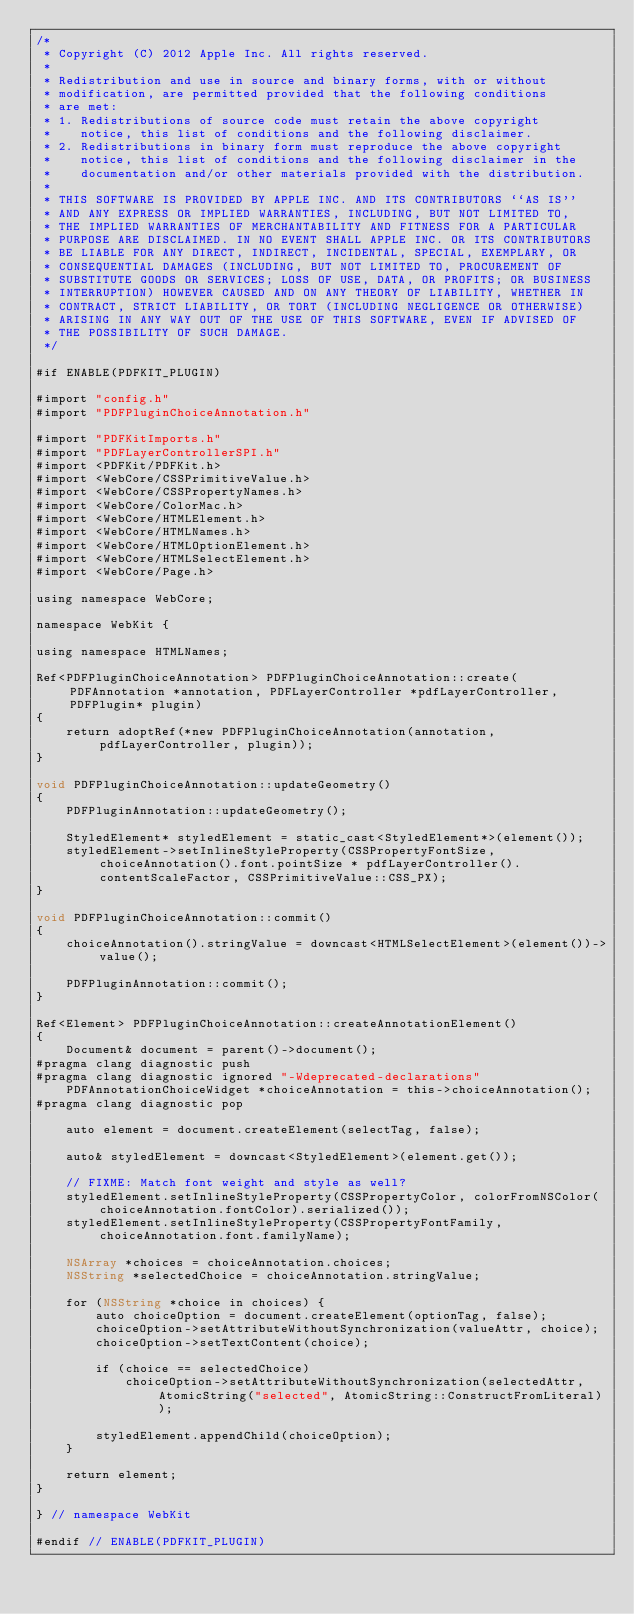<code> <loc_0><loc_0><loc_500><loc_500><_ObjectiveC_>/*
 * Copyright (C) 2012 Apple Inc. All rights reserved.
 *
 * Redistribution and use in source and binary forms, with or without
 * modification, are permitted provided that the following conditions
 * are met:
 * 1. Redistributions of source code must retain the above copyright
 *    notice, this list of conditions and the following disclaimer.
 * 2. Redistributions in binary form must reproduce the above copyright
 *    notice, this list of conditions and the following disclaimer in the
 *    documentation and/or other materials provided with the distribution.
 *
 * THIS SOFTWARE IS PROVIDED BY APPLE INC. AND ITS CONTRIBUTORS ``AS IS''
 * AND ANY EXPRESS OR IMPLIED WARRANTIES, INCLUDING, BUT NOT LIMITED TO,
 * THE IMPLIED WARRANTIES OF MERCHANTABILITY AND FITNESS FOR A PARTICULAR
 * PURPOSE ARE DISCLAIMED. IN NO EVENT SHALL APPLE INC. OR ITS CONTRIBUTORS
 * BE LIABLE FOR ANY DIRECT, INDIRECT, INCIDENTAL, SPECIAL, EXEMPLARY, OR
 * CONSEQUENTIAL DAMAGES (INCLUDING, BUT NOT LIMITED TO, PROCUREMENT OF
 * SUBSTITUTE GOODS OR SERVICES; LOSS OF USE, DATA, OR PROFITS; OR BUSINESS
 * INTERRUPTION) HOWEVER CAUSED AND ON ANY THEORY OF LIABILITY, WHETHER IN
 * CONTRACT, STRICT LIABILITY, OR TORT (INCLUDING NEGLIGENCE OR OTHERWISE)
 * ARISING IN ANY WAY OUT OF THE USE OF THIS SOFTWARE, EVEN IF ADVISED OF
 * THE POSSIBILITY OF SUCH DAMAGE.
 */

#if ENABLE(PDFKIT_PLUGIN)

#import "config.h"
#import "PDFPluginChoiceAnnotation.h"

#import "PDFKitImports.h"
#import "PDFLayerControllerSPI.h"
#import <PDFKit/PDFKit.h>
#import <WebCore/CSSPrimitiveValue.h>
#import <WebCore/CSSPropertyNames.h>
#import <WebCore/ColorMac.h>
#import <WebCore/HTMLElement.h>
#import <WebCore/HTMLNames.h>
#import <WebCore/HTMLOptionElement.h>
#import <WebCore/HTMLSelectElement.h>
#import <WebCore/Page.h>

using namespace WebCore;

namespace WebKit {

using namespace HTMLNames;

Ref<PDFPluginChoiceAnnotation> PDFPluginChoiceAnnotation::create(PDFAnnotation *annotation, PDFLayerController *pdfLayerController, PDFPlugin* plugin)
{
    return adoptRef(*new PDFPluginChoiceAnnotation(annotation, pdfLayerController, plugin));
}

void PDFPluginChoiceAnnotation::updateGeometry()
{
    PDFPluginAnnotation::updateGeometry();

    StyledElement* styledElement = static_cast<StyledElement*>(element());
    styledElement->setInlineStyleProperty(CSSPropertyFontSize, choiceAnnotation().font.pointSize * pdfLayerController().contentScaleFactor, CSSPrimitiveValue::CSS_PX);
}

void PDFPluginChoiceAnnotation::commit()
{
    choiceAnnotation().stringValue = downcast<HTMLSelectElement>(element())->value();

    PDFPluginAnnotation::commit();
}

Ref<Element> PDFPluginChoiceAnnotation::createAnnotationElement()
{
    Document& document = parent()->document();
#pragma clang diagnostic push
#pragma clang diagnostic ignored "-Wdeprecated-declarations"
    PDFAnnotationChoiceWidget *choiceAnnotation = this->choiceAnnotation();
#pragma clang diagnostic pop

    auto element = document.createElement(selectTag, false);

    auto& styledElement = downcast<StyledElement>(element.get());

    // FIXME: Match font weight and style as well?
    styledElement.setInlineStyleProperty(CSSPropertyColor, colorFromNSColor(choiceAnnotation.fontColor).serialized());
    styledElement.setInlineStyleProperty(CSSPropertyFontFamily, choiceAnnotation.font.familyName);

    NSArray *choices = choiceAnnotation.choices;
    NSString *selectedChoice = choiceAnnotation.stringValue;

    for (NSString *choice in choices) {
        auto choiceOption = document.createElement(optionTag, false);
        choiceOption->setAttributeWithoutSynchronization(valueAttr, choice);
        choiceOption->setTextContent(choice);

        if (choice == selectedChoice)
            choiceOption->setAttributeWithoutSynchronization(selectedAttr, AtomicString("selected", AtomicString::ConstructFromLiteral));

        styledElement.appendChild(choiceOption);
    }

    return element;
}

} // namespace WebKit

#endif // ENABLE(PDFKIT_PLUGIN)
</code> 